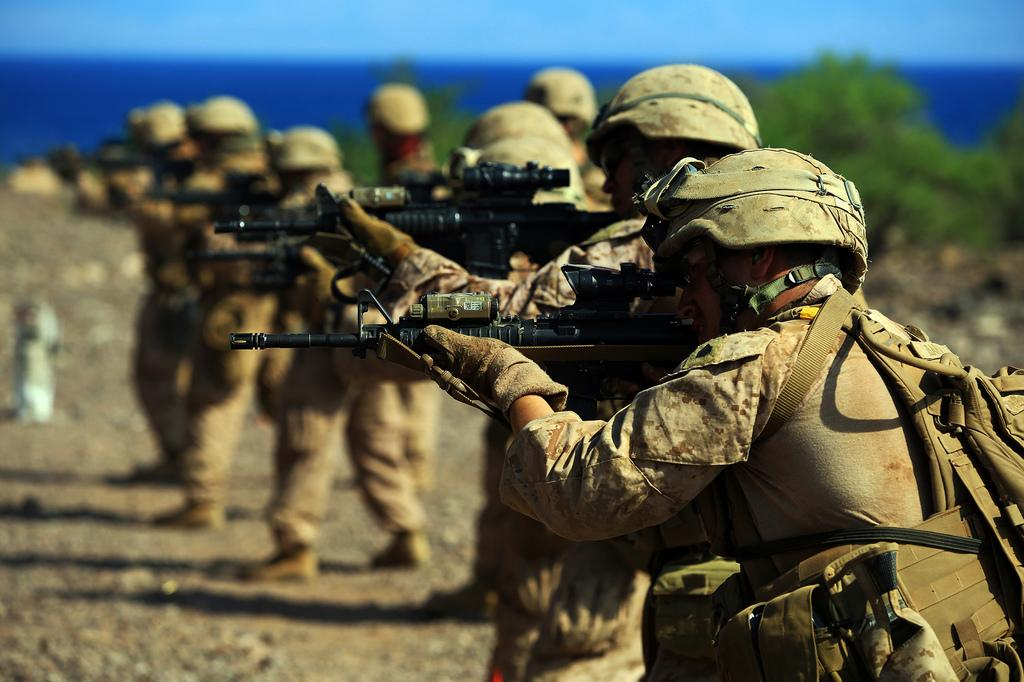What are the people in the center of the image holding? The people in the center of the image are holding guns. What can be seen in the background of the image? There is water and trees visible in the background of the image. How many oranges are being thrown in the image? There are no oranges present in the image. 